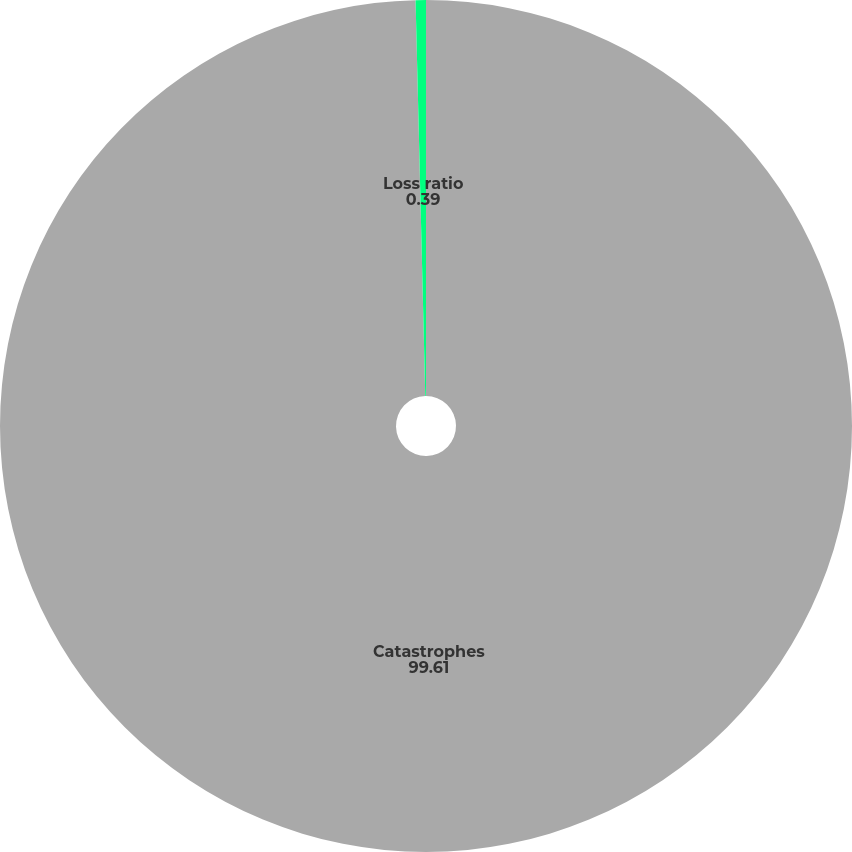Convert chart to OTSL. <chart><loc_0><loc_0><loc_500><loc_500><pie_chart><fcel>Catastrophes<fcel>Loss ratio<nl><fcel>99.61%<fcel>0.39%<nl></chart> 